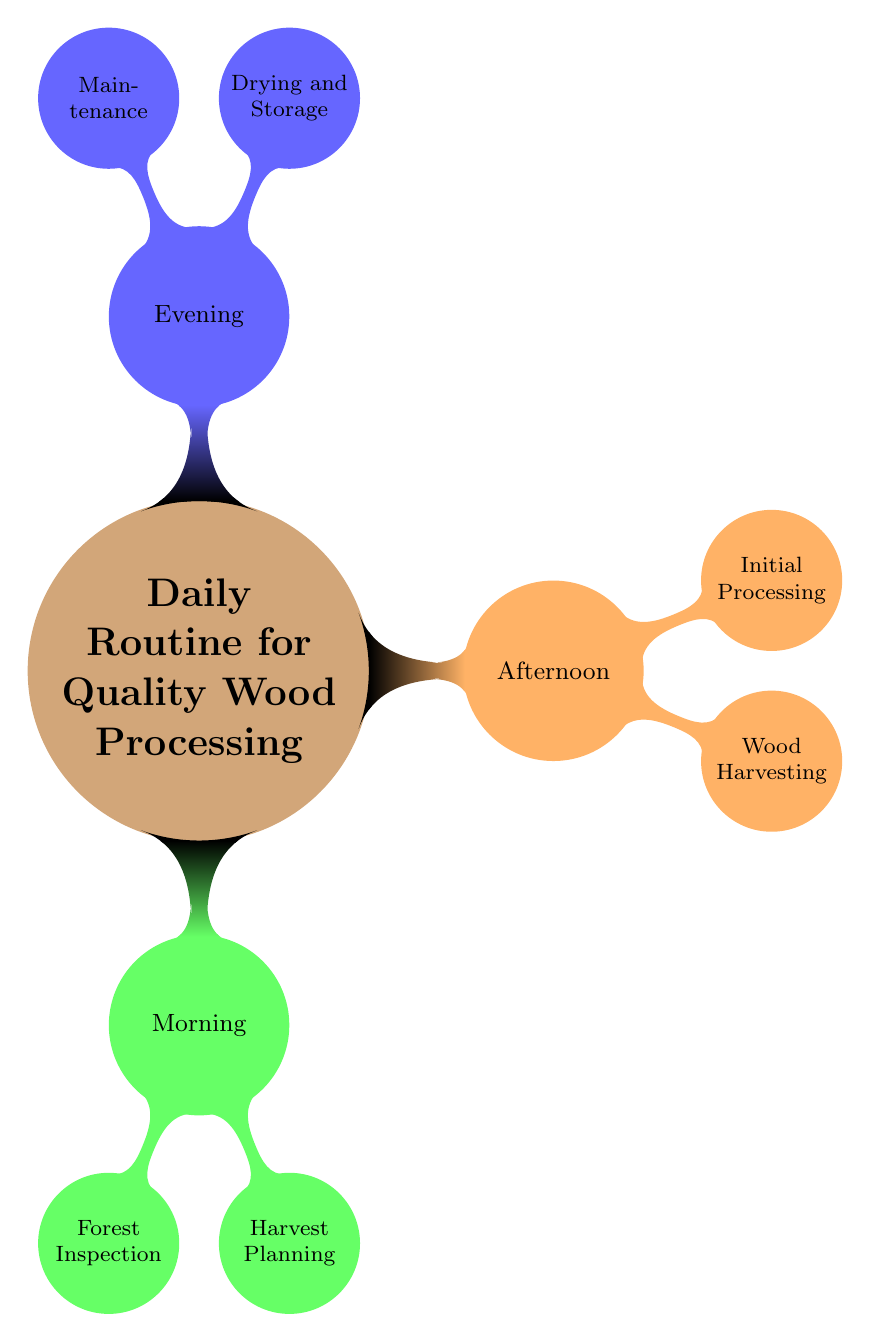What are the three main parts of the daily routine? The diagram clearly shows three main parts of the daily routine: Morning, Afternoon, and Evening, which are the primary divisions of tasks in wood processing.
Answer: Morning, Afternoon, Evening Which specific activity is included in the Morning routine? The Morning part of the routine includes activities such as Forest Inspection and Harvest Planning, both fundamental for starting the day effectively in wood processing.
Answer: Forest Inspection, Harvest Planning How many nodes are there in the Afternoon section? In the Afternoon section, there are two nodes: Wood Harvesting and Initial Processing, which represent the key tasks performed during this time.
Answer: 2 What is the purpose of the Initial Processing? The Initial Processing involves multiple tasks, specifically Debarking, Rough Sawing, and Sorting, which are essential steps in preparing the harvested wood for future use.
Answer: Debarking, Rough Sawing, Sorting Which activity in the Evening routine focuses on tools? The Maintenance activity in the Evening section specifically includes Tool Sharpening, which highlights the importance of keeping tools in good condition for efficient processing.
Answer: Tool Sharpening What is checked during the Forest Inspection? During the Forest Inspection, specific checks are made on Soil Conditions and Tree Health, to ensure the sustainability and quality of the forest environment before any harvesting occurs.
Answer: Check Soil Conditions, Visual Tree Health Assessment Why is Sustainable Practices important in Harvest Planning? Sustainable Practices are crucial in Harvest Planning to minimize ecological disruption, ensuring that the harvesting processes don't negatively impact forest health and biodiversity.
Answer: Minimize ecological disruption What is the first task of the Wood Harvesting process? The first task in the Wood Harvesting process is Tree Cutting, which involves using a chainsaw for making precise cuts, marking the beginning of the harvesting phase.
Answer: Tree Cutting 